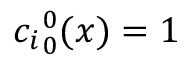<formula> <loc_0><loc_0><loc_500><loc_500>{ c _ { i } } _ { 0 } ^ { 0 } ( x ) = 1</formula> 